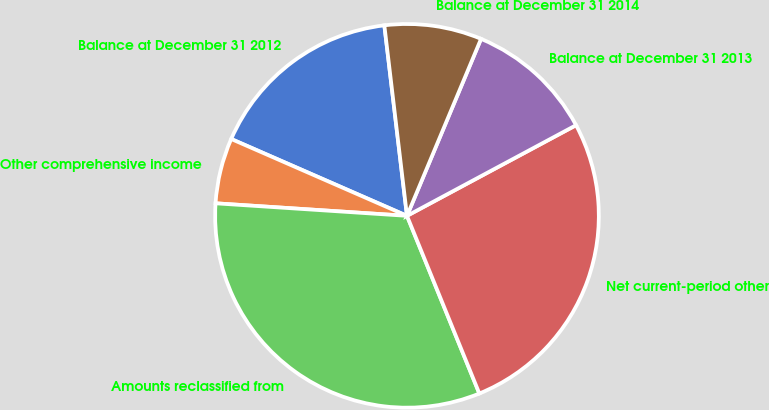Convert chart. <chart><loc_0><loc_0><loc_500><loc_500><pie_chart><fcel>Balance at December 31 2012<fcel>Other comprehensive income<fcel>Amounts reclassified from<fcel>Net current-period other<fcel>Balance at December 31 2013<fcel>Balance at December 31 2014<nl><fcel>16.56%<fcel>5.52%<fcel>32.2%<fcel>26.68%<fcel>10.86%<fcel>8.19%<nl></chart> 